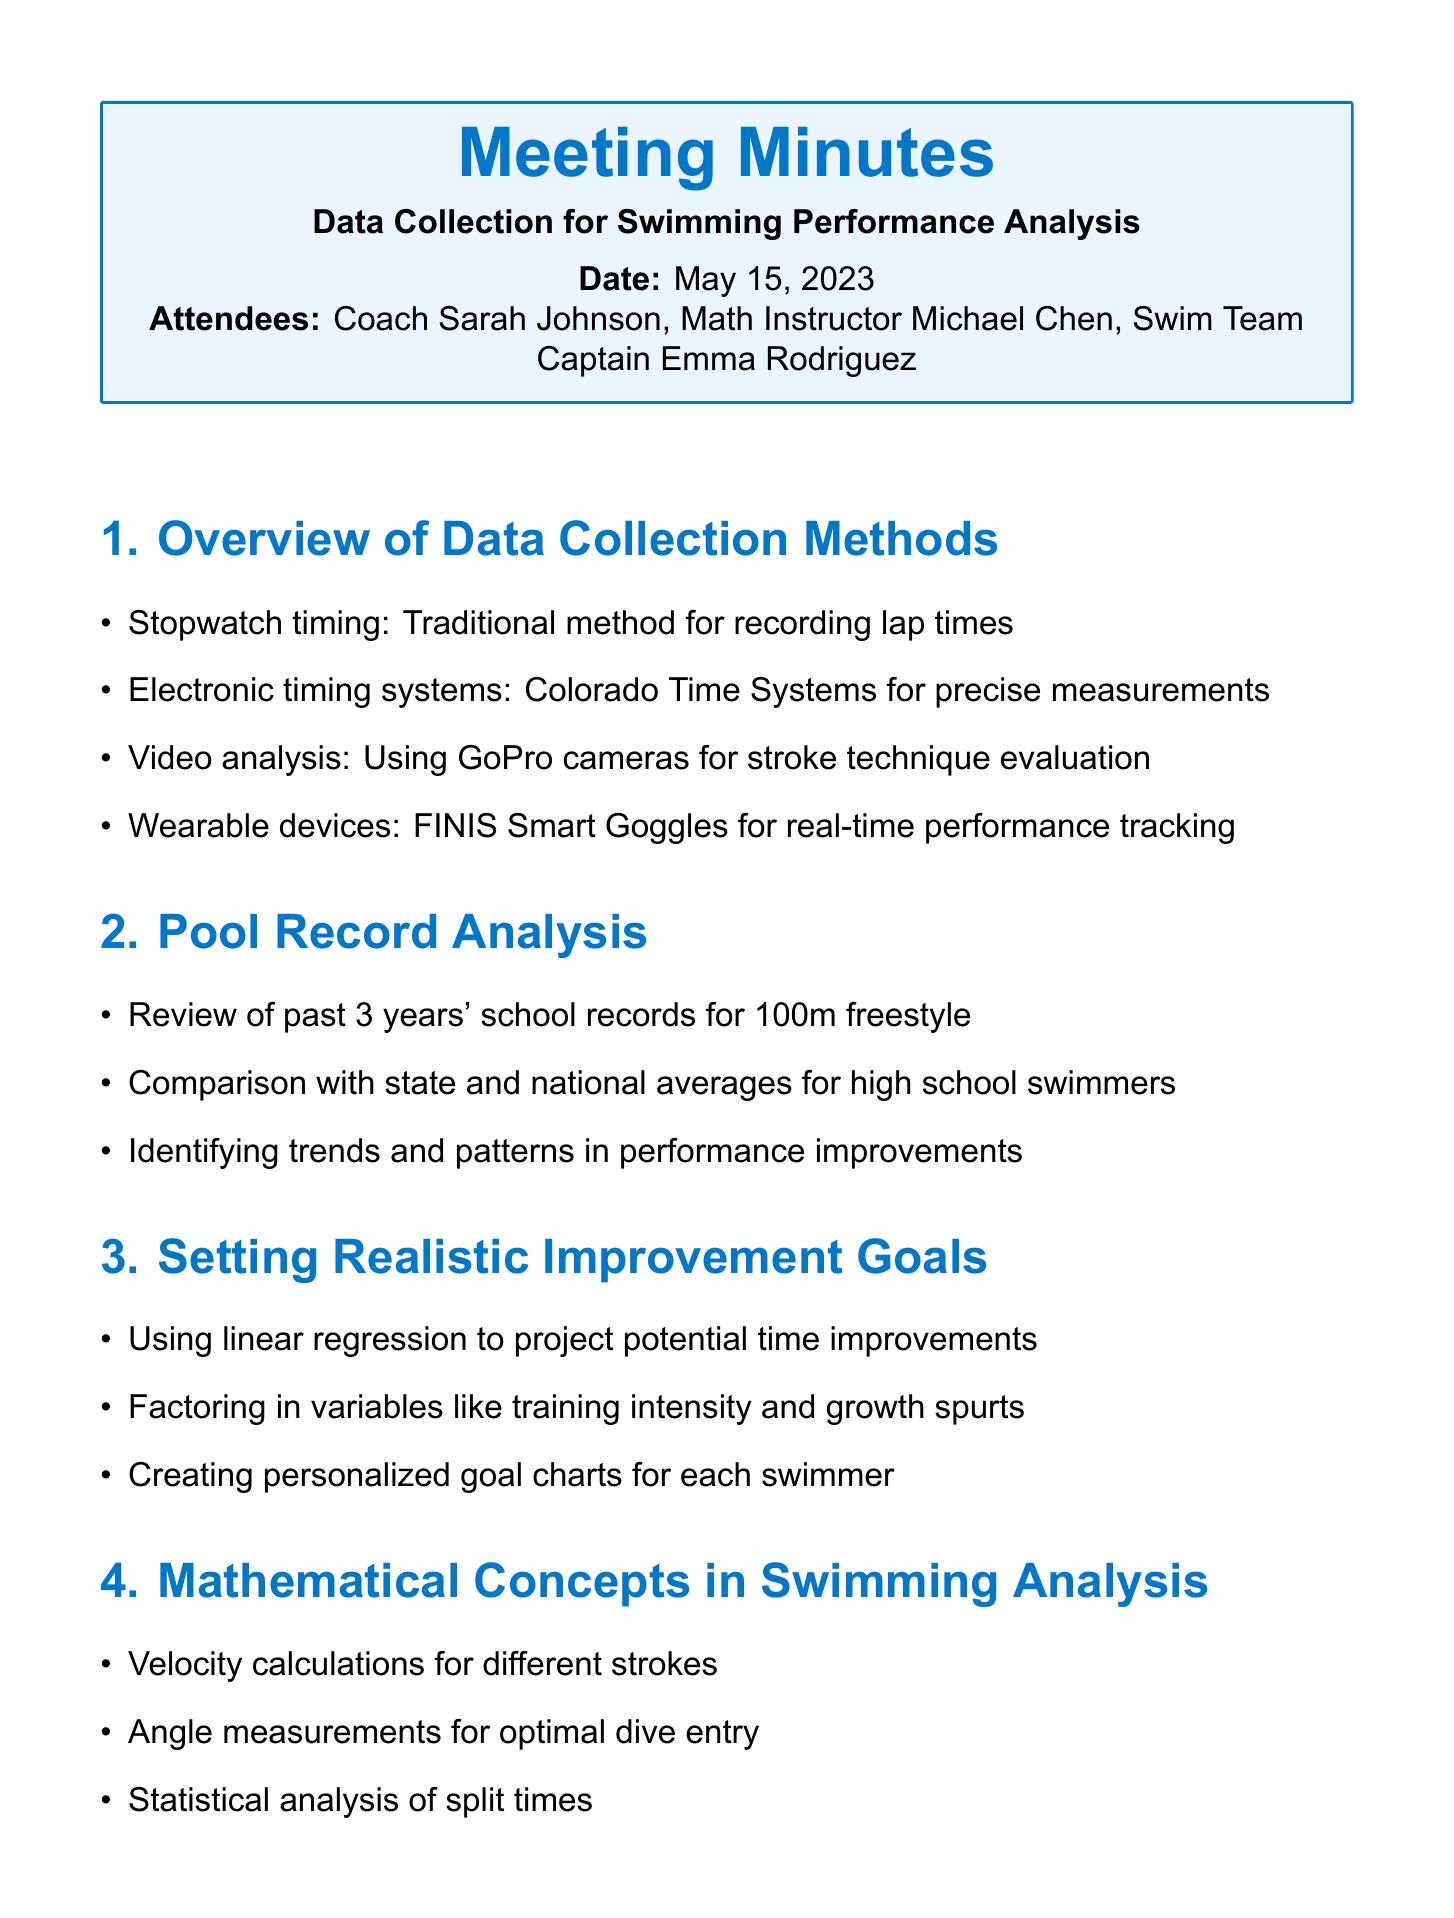What is the date of the meeting? The date of the meeting is provided under the header "Date," which states May 15, 2023.
Answer: May 15, 2023 Who attended the meeting? The names of the attendees are listed at the beginning of the document, under "Attendees."
Answer: Coach Sarah Johnson, Math Instructor Michael Chen, Swim Team Captain Emma Rodriguez What is one method used for stroke technique evaluation? The document lists video analysis using GoPro cameras as one of the methods for evaluating stroke technique.
Answer: Video analysis How many years' records were reviewed for pool analysis? The minutes specify that a review of the past 3 years' school records was conducted for the analysis.
Answer: 3 years What statistical method is mentioned for projecting time improvements? The meeting minutes state that linear regression is used for projecting potential time improvements.
Answer: Linear regression What kind of templates will be developed? The action items include developing a spreadsheet template for tracking individual swimmer progress.
Answer: Spreadsheet template Which device is mentioned for real-time performance tracking? The document specifies that FINIS Smart Goggles are used for real-time performance tracking.
Answer: FINIS Smart Goggles What is an action item related to data collection? The action item includes implementing weekly data collection sessions using an electronic timing system.
Answer: Weekly data collection sessions 